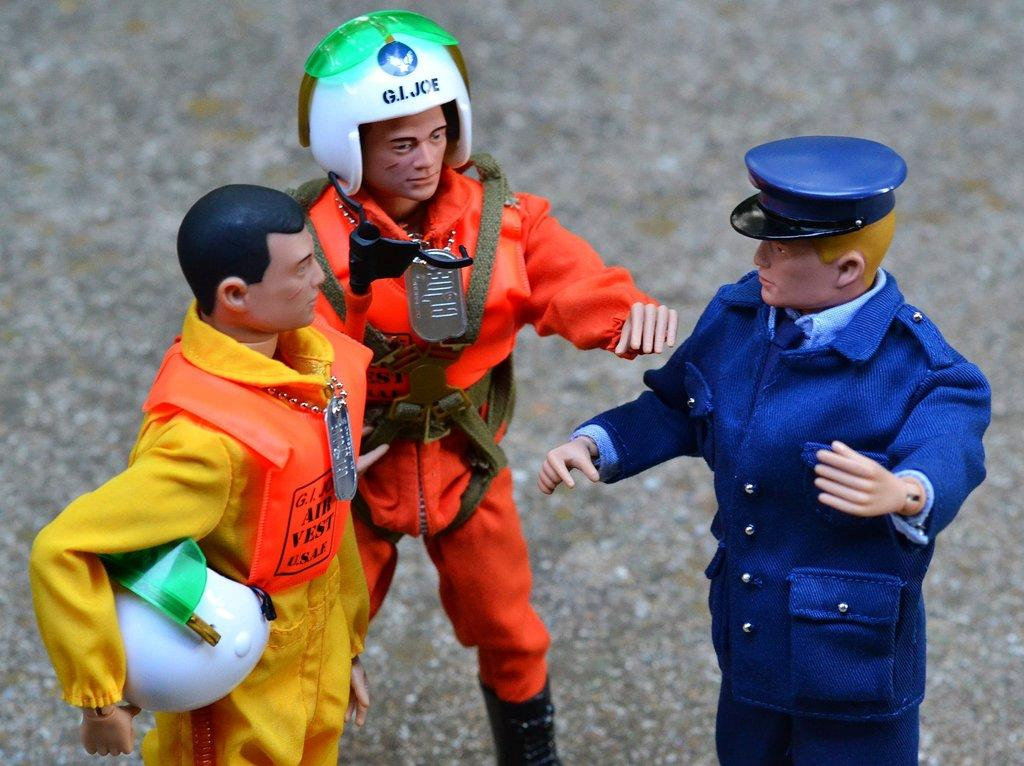How many toys are present in the image? There are three toys in the image. Can you describe the appearance of one of the toys? One toy is wearing a blue dress and a cap. What about another toy in the image? Another toy is wearing an orange dress and a helmet. Is there a woman wearing a judge's robe in the image? No, there is no woman or judge's robe present in the image; it only features three toys. 